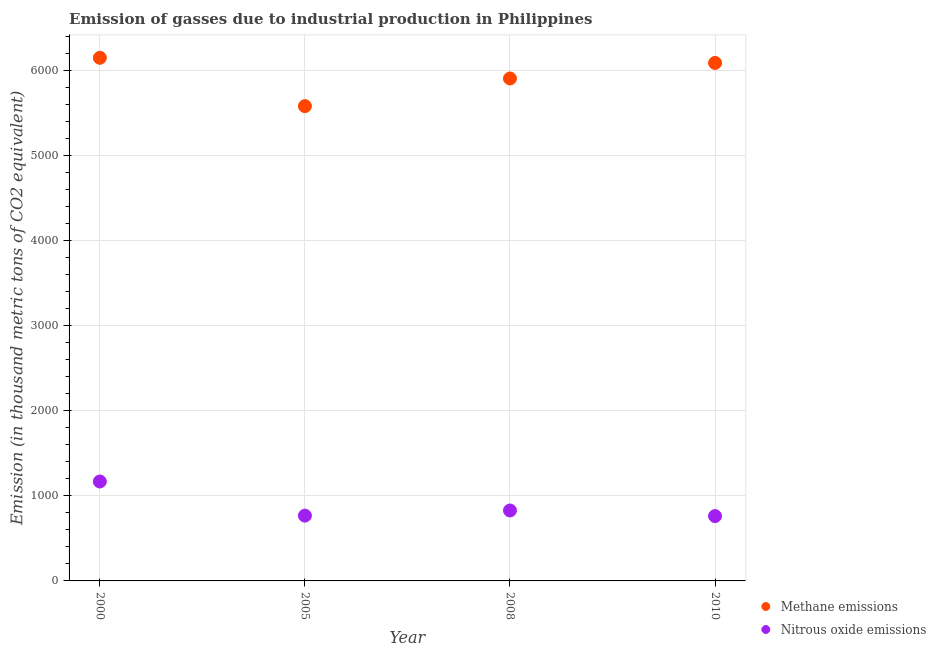How many different coloured dotlines are there?
Your response must be concise. 2. Is the number of dotlines equal to the number of legend labels?
Your answer should be very brief. Yes. What is the amount of methane emissions in 2010?
Provide a short and direct response. 6088.8. Across all years, what is the maximum amount of methane emissions?
Give a very brief answer. 6149.1. Across all years, what is the minimum amount of nitrous oxide emissions?
Provide a short and direct response. 762.1. In which year was the amount of methane emissions minimum?
Your answer should be very brief. 2005. What is the total amount of methane emissions in the graph?
Provide a succinct answer. 2.37e+04. What is the difference between the amount of methane emissions in 2005 and that in 2010?
Ensure brevity in your answer.  -507.9. What is the difference between the amount of nitrous oxide emissions in 2010 and the amount of methane emissions in 2008?
Your response must be concise. -5143.8. What is the average amount of methane emissions per year?
Make the answer very short. 5931.18. In the year 2000, what is the difference between the amount of methane emissions and amount of nitrous oxide emissions?
Your response must be concise. 4980.4. What is the ratio of the amount of nitrous oxide emissions in 2008 to that in 2010?
Your response must be concise. 1.09. What is the difference between the highest and the second highest amount of methane emissions?
Your response must be concise. 60.3. What is the difference between the highest and the lowest amount of methane emissions?
Make the answer very short. 568.2. In how many years, is the amount of methane emissions greater than the average amount of methane emissions taken over all years?
Ensure brevity in your answer.  2. Is the sum of the amount of methane emissions in 2005 and 2010 greater than the maximum amount of nitrous oxide emissions across all years?
Provide a short and direct response. Yes. Is the amount of methane emissions strictly greater than the amount of nitrous oxide emissions over the years?
Ensure brevity in your answer.  Yes. What is the difference between two consecutive major ticks on the Y-axis?
Provide a succinct answer. 1000. Are the values on the major ticks of Y-axis written in scientific E-notation?
Provide a succinct answer. No. Does the graph contain any zero values?
Ensure brevity in your answer.  No. Does the graph contain grids?
Keep it short and to the point. Yes. How are the legend labels stacked?
Make the answer very short. Vertical. What is the title of the graph?
Make the answer very short. Emission of gasses due to industrial production in Philippines. What is the label or title of the Y-axis?
Your response must be concise. Emission (in thousand metric tons of CO2 equivalent). What is the Emission (in thousand metric tons of CO2 equivalent) in Methane emissions in 2000?
Give a very brief answer. 6149.1. What is the Emission (in thousand metric tons of CO2 equivalent) of Nitrous oxide emissions in 2000?
Your response must be concise. 1168.7. What is the Emission (in thousand metric tons of CO2 equivalent) of Methane emissions in 2005?
Offer a terse response. 5580.9. What is the Emission (in thousand metric tons of CO2 equivalent) in Nitrous oxide emissions in 2005?
Your answer should be compact. 767.6. What is the Emission (in thousand metric tons of CO2 equivalent) of Methane emissions in 2008?
Offer a terse response. 5905.9. What is the Emission (in thousand metric tons of CO2 equivalent) in Nitrous oxide emissions in 2008?
Provide a short and direct response. 828. What is the Emission (in thousand metric tons of CO2 equivalent) in Methane emissions in 2010?
Keep it short and to the point. 6088.8. What is the Emission (in thousand metric tons of CO2 equivalent) of Nitrous oxide emissions in 2010?
Keep it short and to the point. 762.1. Across all years, what is the maximum Emission (in thousand metric tons of CO2 equivalent) in Methane emissions?
Keep it short and to the point. 6149.1. Across all years, what is the maximum Emission (in thousand metric tons of CO2 equivalent) in Nitrous oxide emissions?
Give a very brief answer. 1168.7. Across all years, what is the minimum Emission (in thousand metric tons of CO2 equivalent) of Methane emissions?
Your answer should be compact. 5580.9. Across all years, what is the minimum Emission (in thousand metric tons of CO2 equivalent) of Nitrous oxide emissions?
Ensure brevity in your answer.  762.1. What is the total Emission (in thousand metric tons of CO2 equivalent) in Methane emissions in the graph?
Keep it short and to the point. 2.37e+04. What is the total Emission (in thousand metric tons of CO2 equivalent) in Nitrous oxide emissions in the graph?
Your answer should be very brief. 3526.4. What is the difference between the Emission (in thousand metric tons of CO2 equivalent) of Methane emissions in 2000 and that in 2005?
Keep it short and to the point. 568.2. What is the difference between the Emission (in thousand metric tons of CO2 equivalent) of Nitrous oxide emissions in 2000 and that in 2005?
Provide a short and direct response. 401.1. What is the difference between the Emission (in thousand metric tons of CO2 equivalent) in Methane emissions in 2000 and that in 2008?
Offer a very short reply. 243.2. What is the difference between the Emission (in thousand metric tons of CO2 equivalent) of Nitrous oxide emissions in 2000 and that in 2008?
Ensure brevity in your answer.  340.7. What is the difference between the Emission (in thousand metric tons of CO2 equivalent) in Methane emissions in 2000 and that in 2010?
Your answer should be very brief. 60.3. What is the difference between the Emission (in thousand metric tons of CO2 equivalent) in Nitrous oxide emissions in 2000 and that in 2010?
Provide a short and direct response. 406.6. What is the difference between the Emission (in thousand metric tons of CO2 equivalent) in Methane emissions in 2005 and that in 2008?
Offer a terse response. -325. What is the difference between the Emission (in thousand metric tons of CO2 equivalent) in Nitrous oxide emissions in 2005 and that in 2008?
Give a very brief answer. -60.4. What is the difference between the Emission (in thousand metric tons of CO2 equivalent) of Methane emissions in 2005 and that in 2010?
Provide a short and direct response. -507.9. What is the difference between the Emission (in thousand metric tons of CO2 equivalent) of Nitrous oxide emissions in 2005 and that in 2010?
Provide a short and direct response. 5.5. What is the difference between the Emission (in thousand metric tons of CO2 equivalent) in Methane emissions in 2008 and that in 2010?
Your answer should be very brief. -182.9. What is the difference between the Emission (in thousand metric tons of CO2 equivalent) in Nitrous oxide emissions in 2008 and that in 2010?
Your response must be concise. 65.9. What is the difference between the Emission (in thousand metric tons of CO2 equivalent) in Methane emissions in 2000 and the Emission (in thousand metric tons of CO2 equivalent) in Nitrous oxide emissions in 2005?
Ensure brevity in your answer.  5381.5. What is the difference between the Emission (in thousand metric tons of CO2 equivalent) in Methane emissions in 2000 and the Emission (in thousand metric tons of CO2 equivalent) in Nitrous oxide emissions in 2008?
Ensure brevity in your answer.  5321.1. What is the difference between the Emission (in thousand metric tons of CO2 equivalent) of Methane emissions in 2000 and the Emission (in thousand metric tons of CO2 equivalent) of Nitrous oxide emissions in 2010?
Provide a succinct answer. 5387. What is the difference between the Emission (in thousand metric tons of CO2 equivalent) in Methane emissions in 2005 and the Emission (in thousand metric tons of CO2 equivalent) in Nitrous oxide emissions in 2008?
Your answer should be very brief. 4752.9. What is the difference between the Emission (in thousand metric tons of CO2 equivalent) in Methane emissions in 2005 and the Emission (in thousand metric tons of CO2 equivalent) in Nitrous oxide emissions in 2010?
Your response must be concise. 4818.8. What is the difference between the Emission (in thousand metric tons of CO2 equivalent) in Methane emissions in 2008 and the Emission (in thousand metric tons of CO2 equivalent) in Nitrous oxide emissions in 2010?
Keep it short and to the point. 5143.8. What is the average Emission (in thousand metric tons of CO2 equivalent) in Methane emissions per year?
Ensure brevity in your answer.  5931.18. What is the average Emission (in thousand metric tons of CO2 equivalent) of Nitrous oxide emissions per year?
Offer a terse response. 881.6. In the year 2000, what is the difference between the Emission (in thousand metric tons of CO2 equivalent) in Methane emissions and Emission (in thousand metric tons of CO2 equivalent) in Nitrous oxide emissions?
Give a very brief answer. 4980.4. In the year 2005, what is the difference between the Emission (in thousand metric tons of CO2 equivalent) in Methane emissions and Emission (in thousand metric tons of CO2 equivalent) in Nitrous oxide emissions?
Provide a succinct answer. 4813.3. In the year 2008, what is the difference between the Emission (in thousand metric tons of CO2 equivalent) of Methane emissions and Emission (in thousand metric tons of CO2 equivalent) of Nitrous oxide emissions?
Make the answer very short. 5077.9. In the year 2010, what is the difference between the Emission (in thousand metric tons of CO2 equivalent) in Methane emissions and Emission (in thousand metric tons of CO2 equivalent) in Nitrous oxide emissions?
Your response must be concise. 5326.7. What is the ratio of the Emission (in thousand metric tons of CO2 equivalent) of Methane emissions in 2000 to that in 2005?
Your answer should be compact. 1.1. What is the ratio of the Emission (in thousand metric tons of CO2 equivalent) of Nitrous oxide emissions in 2000 to that in 2005?
Provide a succinct answer. 1.52. What is the ratio of the Emission (in thousand metric tons of CO2 equivalent) in Methane emissions in 2000 to that in 2008?
Keep it short and to the point. 1.04. What is the ratio of the Emission (in thousand metric tons of CO2 equivalent) of Nitrous oxide emissions in 2000 to that in 2008?
Your answer should be very brief. 1.41. What is the ratio of the Emission (in thousand metric tons of CO2 equivalent) of Methane emissions in 2000 to that in 2010?
Provide a short and direct response. 1.01. What is the ratio of the Emission (in thousand metric tons of CO2 equivalent) in Nitrous oxide emissions in 2000 to that in 2010?
Make the answer very short. 1.53. What is the ratio of the Emission (in thousand metric tons of CO2 equivalent) of Methane emissions in 2005 to that in 2008?
Provide a succinct answer. 0.94. What is the ratio of the Emission (in thousand metric tons of CO2 equivalent) of Nitrous oxide emissions in 2005 to that in 2008?
Your response must be concise. 0.93. What is the ratio of the Emission (in thousand metric tons of CO2 equivalent) of Methane emissions in 2005 to that in 2010?
Provide a succinct answer. 0.92. What is the ratio of the Emission (in thousand metric tons of CO2 equivalent) in Nitrous oxide emissions in 2008 to that in 2010?
Give a very brief answer. 1.09. What is the difference between the highest and the second highest Emission (in thousand metric tons of CO2 equivalent) of Methane emissions?
Offer a very short reply. 60.3. What is the difference between the highest and the second highest Emission (in thousand metric tons of CO2 equivalent) of Nitrous oxide emissions?
Offer a terse response. 340.7. What is the difference between the highest and the lowest Emission (in thousand metric tons of CO2 equivalent) of Methane emissions?
Provide a succinct answer. 568.2. What is the difference between the highest and the lowest Emission (in thousand metric tons of CO2 equivalent) in Nitrous oxide emissions?
Offer a very short reply. 406.6. 